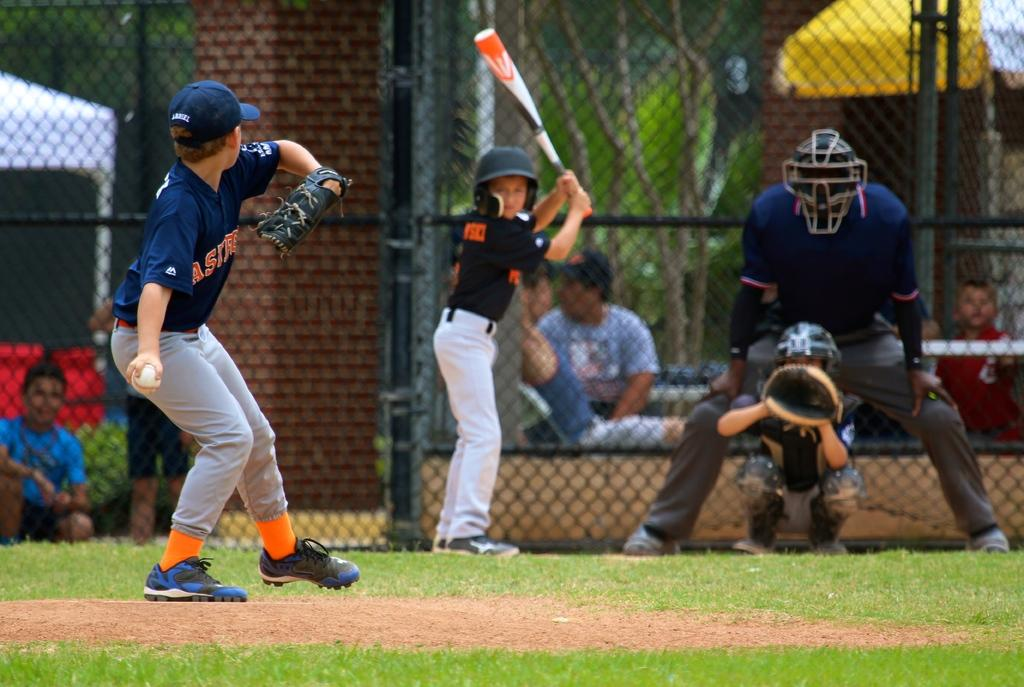<image>
Offer a succinct explanation of the picture presented. An Astros pitcher throws a pitch to a batter. 